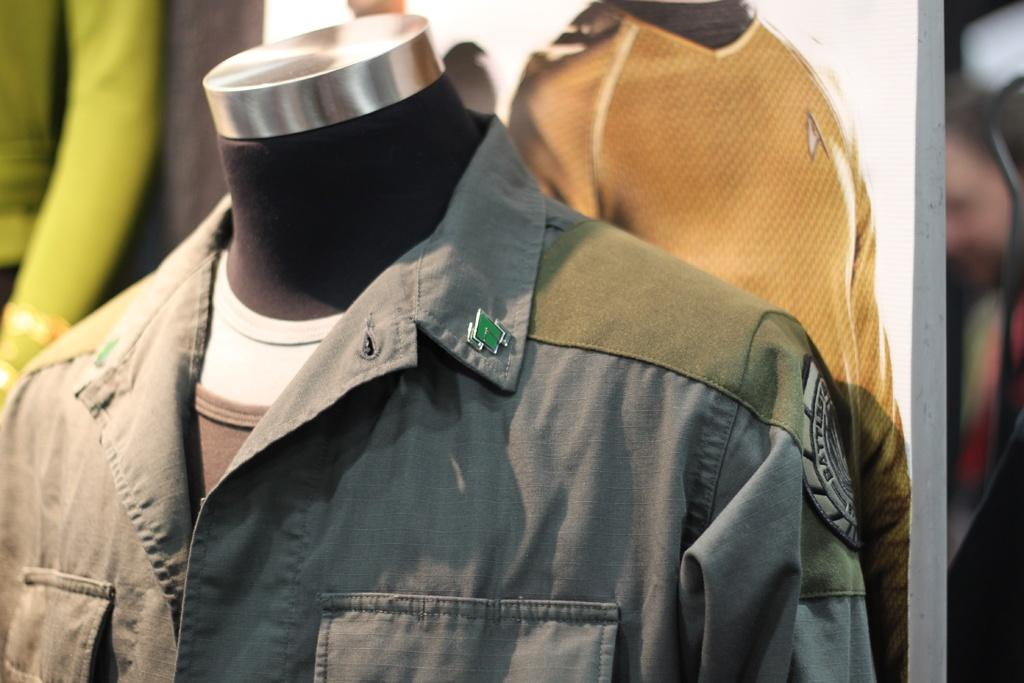What is on the mannequin in the image? There is a shirt on a mannequin in the image. What can be seen in the background of the image? There is a board visible in the background of the image. How many mice can be seen running around the mannequin in the image? There are no mice present in the image; it only features a shirt on a mannequin and a board in the background. 